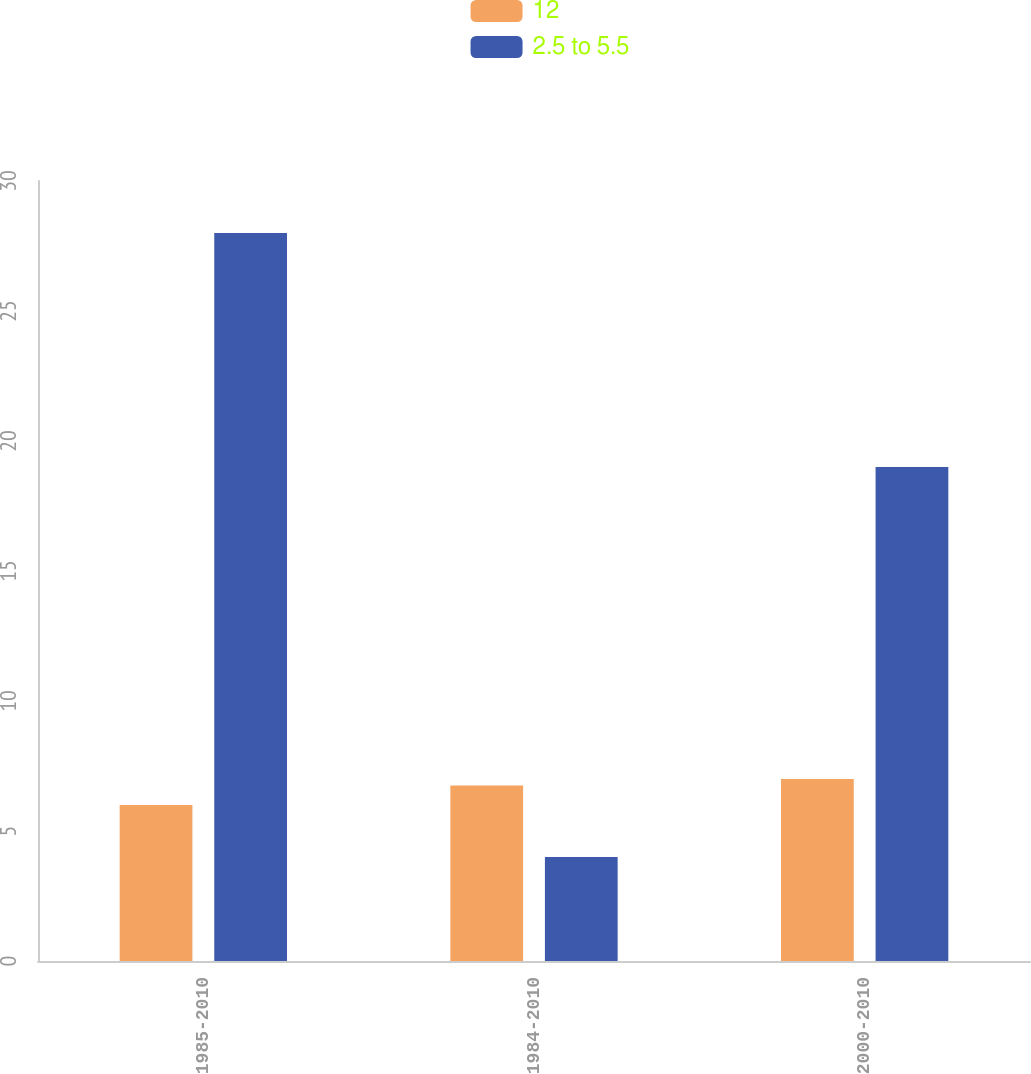Convert chart to OTSL. <chart><loc_0><loc_0><loc_500><loc_500><stacked_bar_chart><ecel><fcel>1985-2010<fcel>1984-2010<fcel>2000-2010<nl><fcel>12<fcel>6<fcel>6.75<fcel>7<nl><fcel>2.5 to 5.5<fcel>28<fcel>4<fcel>19<nl></chart> 